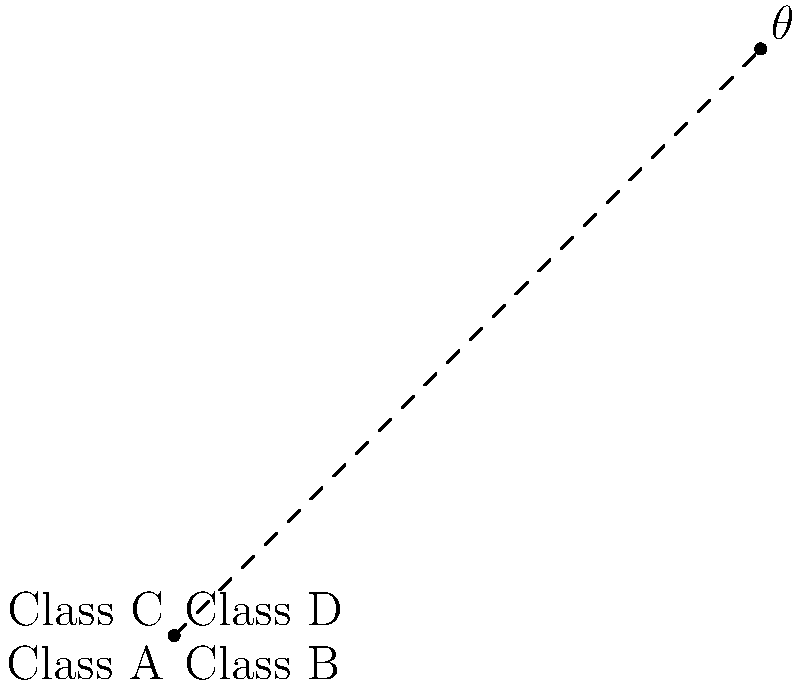In a UML class diagram, two association lines intersect at an angle. Given that the coordinates of the four classes are A(0,0), B(4,0), C(1,3), and D(4,3), calculate the angle $\theta$ between the two intersecting lines AB and CD. To calculate the angle between two intersecting lines, we can follow these steps:

1. Calculate the slopes of both lines:
   Line AB: $m_{AB} = \frac{y_B - y_A}{x_B - x_A} = \frac{0 - 0}{4 - 0} = 0$
   Line CD: $m_{CD} = \frac{y_D - y_C}{x_D - x_C} = \frac{3 - 3}{4 - 1} = 0$

2. Use the formula for the angle between two lines:
   $\tan \theta = |\frac{m_1 - m_2}{1 + m_1m_2}|$

3. Substitute the slopes into the formula:
   $\tan \theta = |\frac{0 - 0}{1 + 0 \cdot 0}| = 0$

4. Take the inverse tangent (arctangent) of both sides:
   $\theta = \arctan(0)$

5. Evaluate the result:
   $\theta = 0°$

The angle between the two intersecting lines is 0°, which means they are parallel.

This result aligns with the visual representation in the UML diagram, where the association lines between Class A and Class B, and between Class C and Class D, are indeed parallel.
Answer: $0°$ 